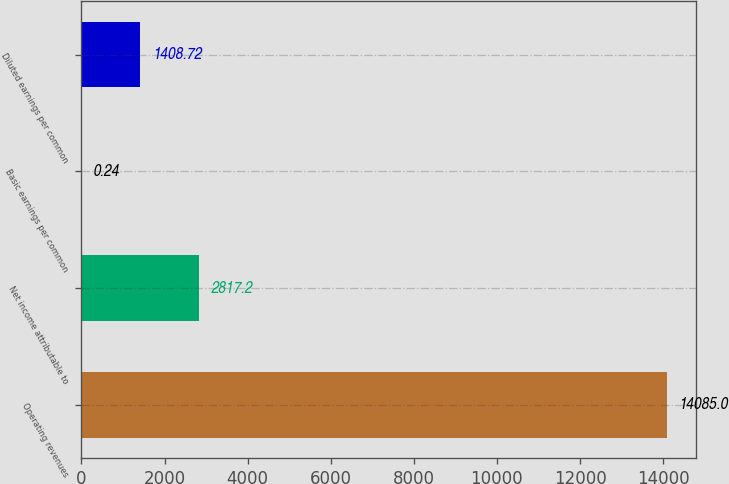Convert chart to OTSL. <chart><loc_0><loc_0><loc_500><loc_500><bar_chart><fcel>Operating revenues<fcel>Net income attributable to<fcel>Basic earnings per common<fcel>Diluted earnings per common<nl><fcel>14085<fcel>2817.2<fcel>0.24<fcel>1408.72<nl></chart> 